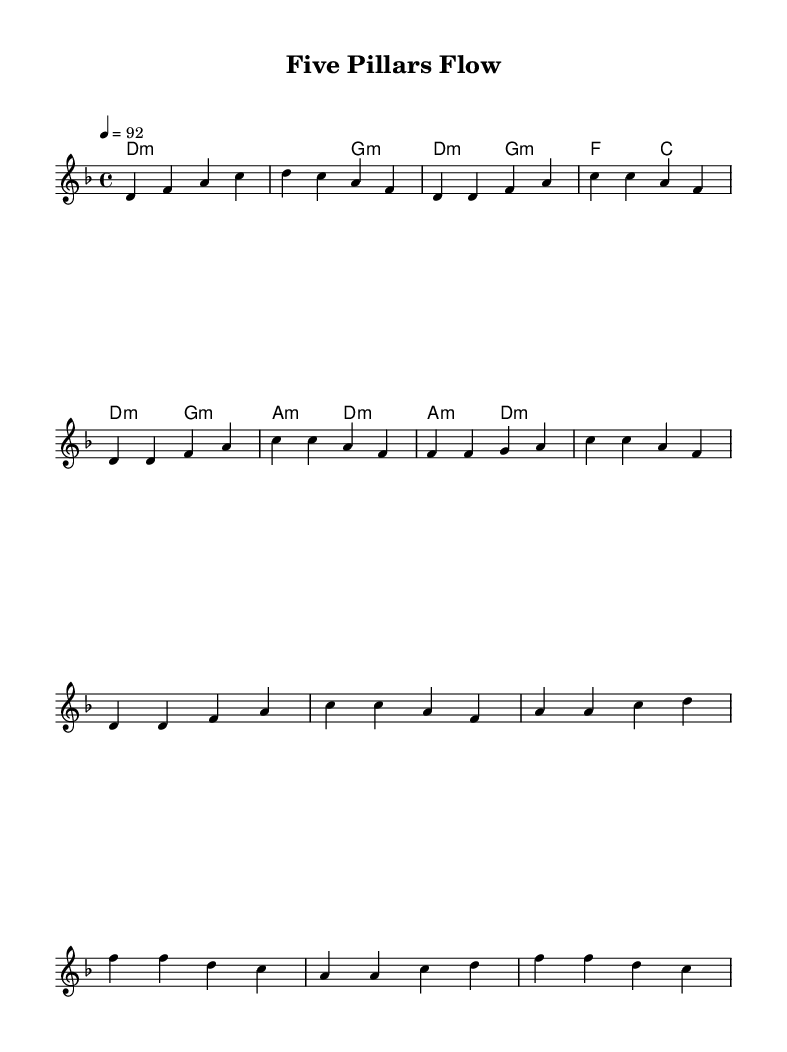What is the key signature of this music? The key signature is D minor, which typically contains one flat (B flat). This can be determined by checking the key signature indicators at the beginning of the staff.
Answer: D minor What is the time signature of this music? The time signature is 4/4, indicated at the beginning of the score. This means there are four beats in a measure, and the quarter note gets one beat.
Answer: 4/4 What is the tempo marking for this piece? The tempo is marked as quarter note equals 92. This shows the speed at which the piece should be played, indicated at the top of the score.
Answer: 92 How many measures are there in the intro? The intro consists of two measures, as shown in the notation at the beginning of the piece where two vocal phrases are captured.
Answer: 2 Which form is used in the melody of this rap? The form used in the rap follows a verse-chorus structure, typical of rap music, with repeated patterns indicating structure. This is determined by the ordering of the melody sections labeled as "Verse" and "Chorus".
Answer: Verse-Chorus What chord is used during the bridge section? The chord used during the bridge is A minor, which is indicated in the chord progression under the corresponding measure for that section.
Answer: A minor What is the motif repeated in the chorus? The motif repeated in the chorus is the pattern of the notes F, C, A, F, which is the melodic line showcased multiple times in the chorus section.
Answer: F, C, A, F 